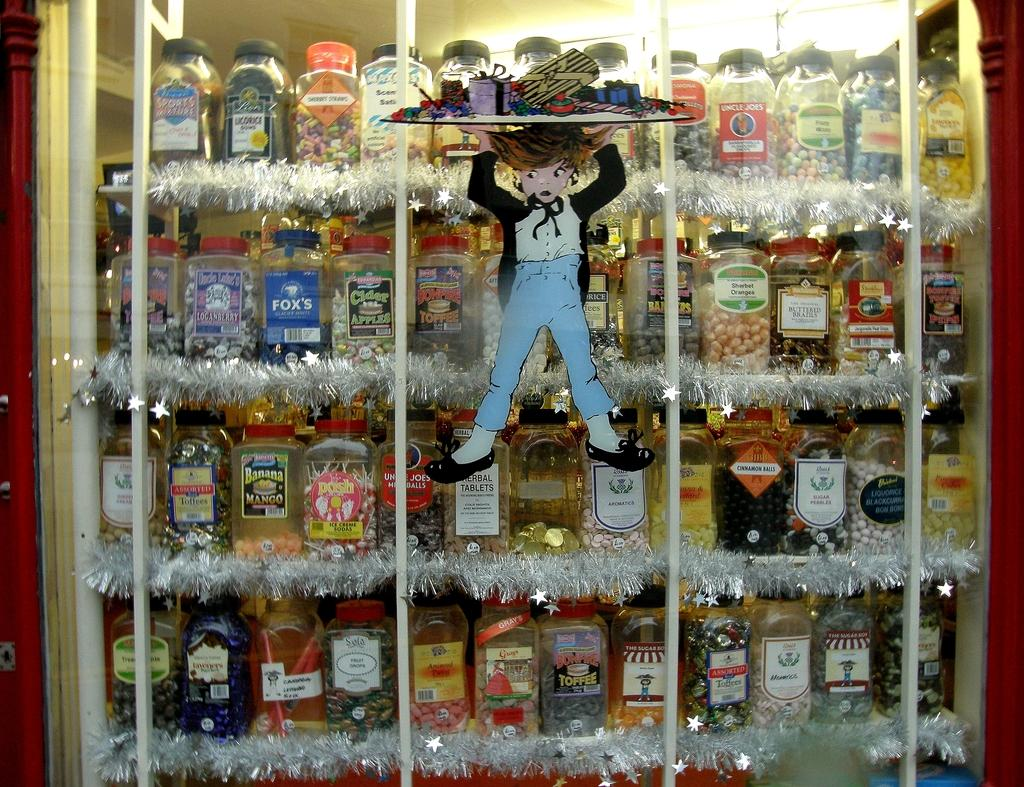<image>
Share a concise interpretation of the image provided. A display case of many different types of candy in jars includes Ice Creme Soda suckers, Bonfire Toffee, Banana Mango, and Cider Apples plus many more. 